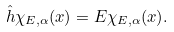Convert formula to latex. <formula><loc_0><loc_0><loc_500><loc_500>\hat { h } \chi _ { E , \alpha } ( x ) = E \chi _ { E , \alpha } ( x ) .</formula> 